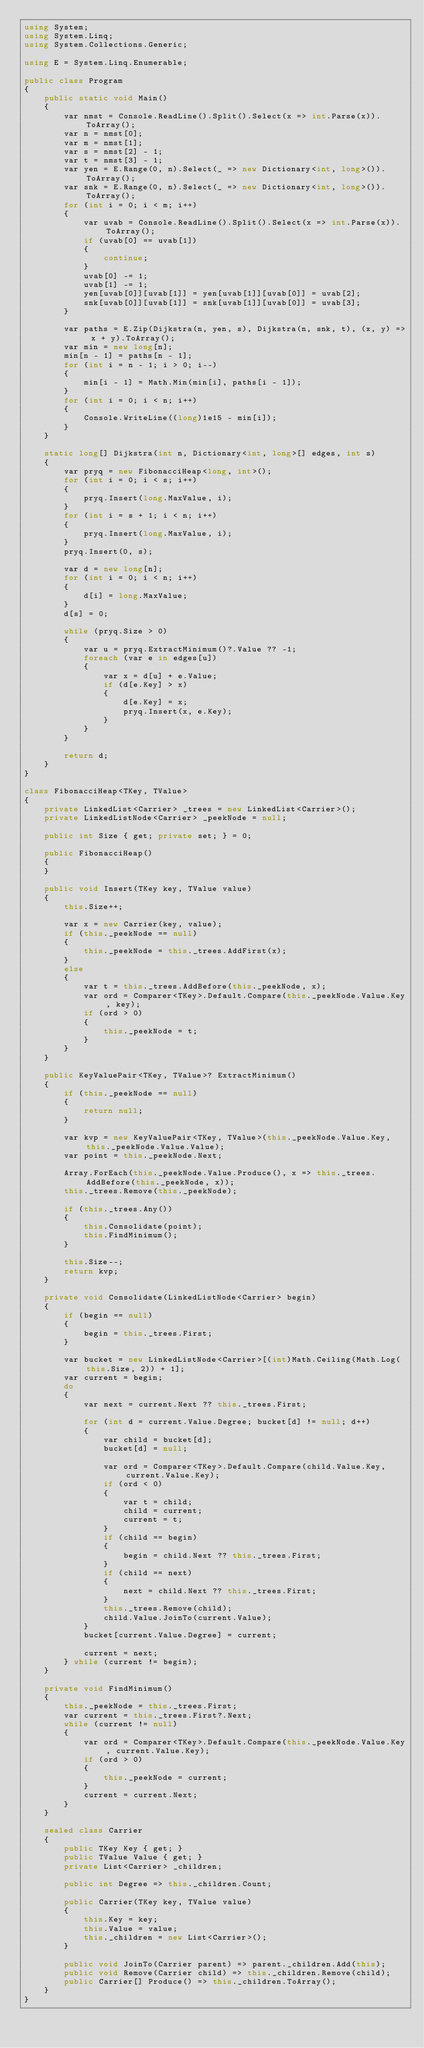<code> <loc_0><loc_0><loc_500><loc_500><_C#_>using System;
using System.Linq;
using System.Collections.Generic;

using E = System.Linq.Enumerable;

public class Program
{
    public static void Main()
    {
        var nmst = Console.ReadLine().Split().Select(x => int.Parse(x)).ToArray();
        var n = nmst[0];
        var m = nmst[1];
        var s = nmst[2] - 1;
        var t = nmst[3] - 1;
        var yen = E.Range(0, n).Select(_ => new Dictionary<int, long>()).ToArray();
        var snk = E.Range(0, n).Select(_ => new Dictionary<int, long>()).ToArray();
        for (int i = 0; i < m; i++)
        {
            var uvab = Console.ReadLine().Split().Select(x => int.Parse(x)).ToArray();
            if (uvab[0] == uvab[1])
            {
                continue;
            }
            uvab[0] -= 1;
            uvab[1] -= 1;
            yen[uvab[0]][uvab[1]] = yen[uvab[1]][uvab[0]] = uvab[2];
            snk[uvab[0]][uvab[1]] = snk[uvab[1]][uvab[0]] = uvab[3];
        }

        var paths = E.Zip(Dijkstra(n, yen, s), Dijkstra(n, snk, t), (x, y) => x + y).ToArray();
        var min = new long[n];
        min[n - 1] = paths[n - 1];
        for (int i = n - 1; i > 0; i--)
        {
            min[i - 1] = Math.Min(min[i], paths[i - 1]);
        }
        for (int i = 0; i < n; i++)
        {
            Console.WriteLine((long)1e15 - min[i]);
        }
    }

    static long[] Dijkstra(int n, Dictionary<int, long>[] edges, int s)
    {
        var pryq = new FibonacciHeap<long, int>();
        for (int i = 0; i < s; i++)
        {
            pryq.Insert(long.MaxValue, i);
        }
        for (int i = s + 1; i < n; i++)
        {
            pryq.Insert(long.MaxValue, i);
        }
        pryq.Insert(0, s);

        var d = new long[n];
        for (int i = 0; i < n; i++)
        {
            d[i] = long.MaxValue;
        }
        d[s] = 0;

        while (pryq.Size > 0)
        {
            var u = pryq.ExtractMinimum()?.Value ?? -1;
            foreach (var e in edges[u])
            {
                var x = d[u] + e.Value;
                if (d[e.Key] > x)
                {
                    d[e.Key] = x;
                    pryq.Insert(x, e.Key);
                }
            }
        }

        return d;
    }
}

class FibonacciHeap<TKey, TValue>
{
    private LinkedList<Carrier> _trees = new LinkedList<Carrier>();
    private LinkedListNode<Carrier> _peekNode = null;

    public int Size { get; private set; } = 0;

    public FibonacciHeap()
    {
    }

    public void Insert(TKey key, TValue value)
    {
        this.Size++;

        var x = new Carrier(key, value);
        if (this._peekNode == null)
        {
            this._peekNode = this._trees.AddFirst(x);
        }
        else
        {
            var t = this._trees.AddBefore(this._peekNode, x);
            var ord = Comparer<TKey>.Default.Compare(this._peekNode.Value.Key, key);
            if (ord > 0)
            {
                this._peekNode = t;
            }
        }
    }

    public KeyValuePair<TKey, TValue>? ExtractMinimum()
    {
        if (this._peekNode == null)
        {
            return null;
        }

        var kvp = new KeyValuePair<TKey, TValue>(this._peekNode.Value.Key, this._peekNode.Value.Value);
        var point = this._peekNode.Next;

        Array.ForEach(this._peekNode.Value.Produce(), x => this._trees.AddBefore(this._peekNode, x));
        this._trees.Remove(this._peekNode);

        if (this._trees.Any())
        {
            this.Consolidate(point);
            this.FindMinimum();
        }

        this.Size--;
        return kvp;
    }

    private void Consolidate(LinkedListNode<Carrier> begin)
    {
        if (begin == null)
        {
            begin = this._trees.First;
        }

        var bucket = new LinkedListNode<Carrier>[(int)Math.Ceiling(Math.Log(this.Size, 2)) + 1];
        var current = begin;
        do
        {
            var next = current.Next ?? this._trees.First;

            for (int d = current.Value.Degree; bucket[d] != null; d++)
            {
                var child = bucket[d];
                bucket[d] = null;

                var ord = Comparer<TKey>.Default.Compare(child.Value.Key, current.Value.Key);
                if (ord < 0)
                {
                    var t = child;
                    child = current;
                    current = t;
                }
                if (child == begin)
                {
                    begin = child.Next ?? this._trees.First;
                }
                if (child == next)
                {
                    next = child.Next ?? this._trees.First;
                }
                this._trees.Remove(child);
                child.Value.JoinTo(current.Value);
            }
            bucket[current.Value.Degree] = current;

            current = next;
        } while (current != begin);
    }

    private void FindMinimum()
    {
        this._peekNode = this._trees.First;
        var current = this._trees.First?.Next;
        while (current != null)
        {
            var ord = Comparer<TKey>.Default.Compare(this._peekNode.Value.Key, current.Value.Key);
            if (ord > 0)
            {
                this._peekNode = current;
            }
            current = current.Next;
        }
    }

    sealed class Carrier
    {
        public TKey Key { get; }
        public TValue Value { get; }
        private List<Carrier> _children;

        public int Degree => this._children.Count;

        public Carrier(TKey key, TValue value)
        {
            this.Key = key;
            this.Value = value;
            this._children = new List<Carrier>();
        }

        public void JoinTo(Carrier parent) => parent._children.Add(this);
        public void Remove(Carrier child) => this._children.Remove(child);
        public Carrier[] Produce() => this._children.ToArray();
    }
}</code> 